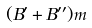Convert formula to latex. <formula><loc_0><loc_0><loc_500><loc_500>( B ^ { \prime } + B ^ { \prime \prime } ) m</formula> 